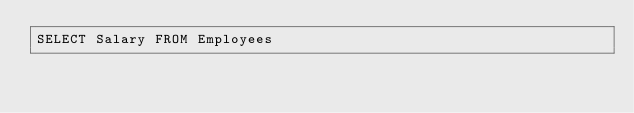Convert code to text. <code><loc_0><loc_0><loc_500><loc_500><_SQL_>SELECT Salary FROM Employees</code> 